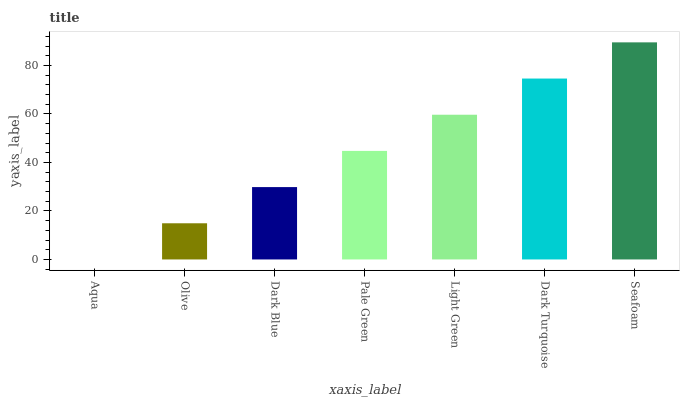Is Aqua the minimum?
Answer yes or no. Yes. Is Seafoam the maximum?
Answer yes or no. Yes. Is Olive the minimum?
Answer yes or no. No. Is Olive the maximum?
Answer yes or no. No. Is Olive greater than Aqua?
Answer yes or no. Yes. Is Aqua less than Olive?
Answer yes or no. Yes. Is Aqua greater than Olive?
Answer yes or no. No. Is Olive less than Aqua?
Answer yes or no. No. Is Pale Green the high median?
Answer yes or no. Yes. Is Pale Green the low median?
Answer yes or no. Yes. Is Aqua the high median?
Answer yes or no. No. Is Light Green the low median?
Answer yes or no. No. 